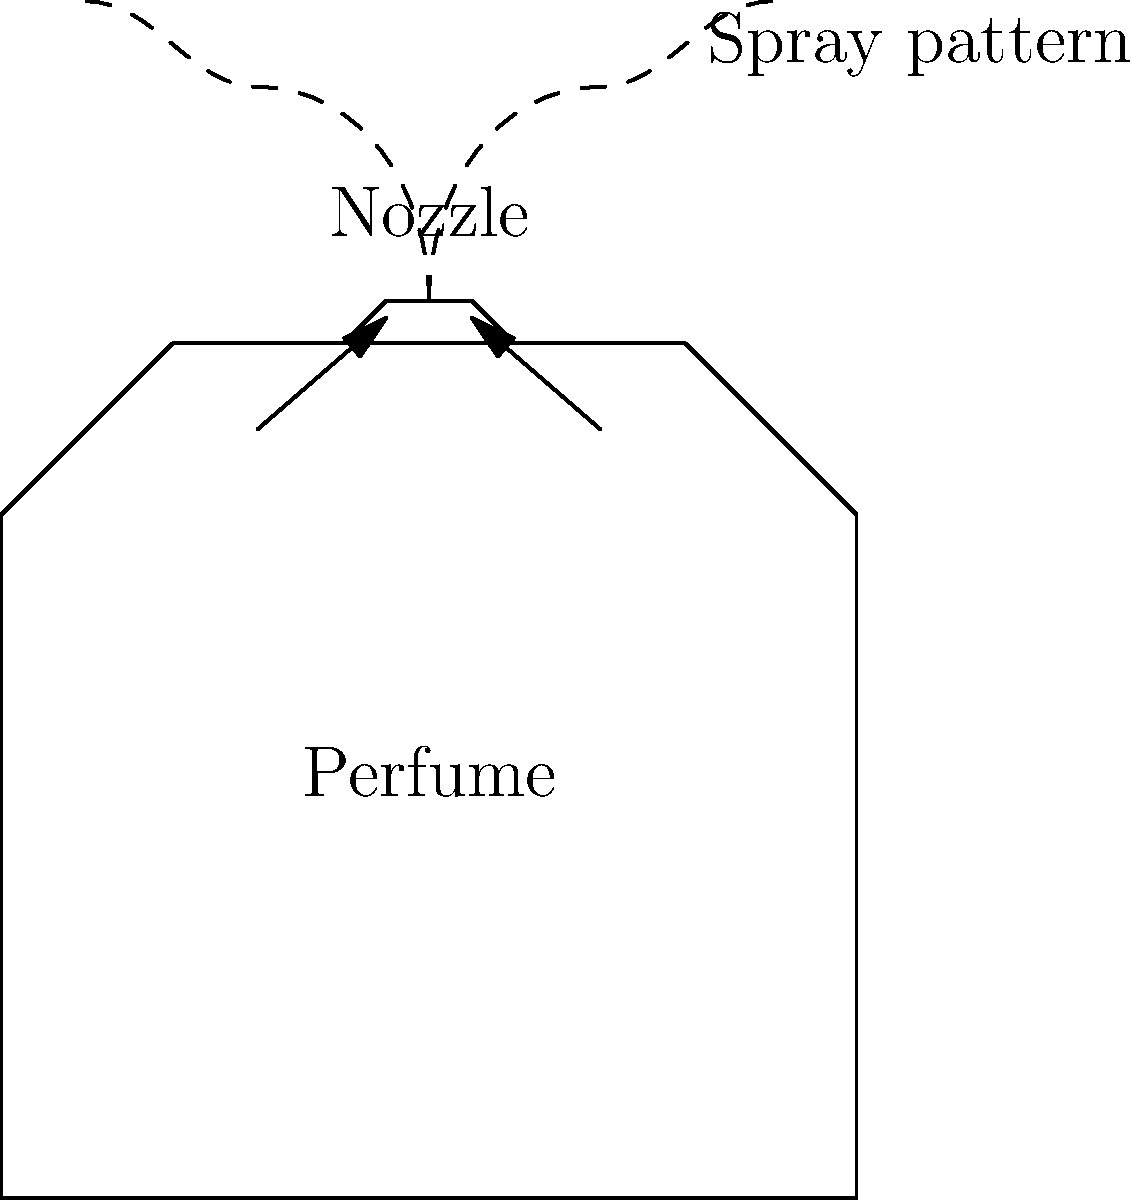In luxury perfume atomizers, the spray pattern is crucial for the perceived quality of the product. Consider a high-end perfume atomizer that produces a fine mist with a cone angle of 30°. If the initial velocity of the perfume droplets is 15 m/s and they have an average diameter of 20 μm, estimate the maximum distance these droplets can travel horizontally before falling 1 m vertically. Assume standard gravity (g = 9.81 m/s²) and neglect air resistance. To solve this problem, we'll follow these steps:

1) First, we need to determine the time it takes for the droplet to fall 1 m vertically.
   Using the equation of motion: $y = \frac{1}{2}gt^2$
   Where $y = 1$ m, $g = 9.81$ m/s²
   
   $1 = \frac{1}{2} \cdot 9.81 \cdot t^2$
   $t = \sqrt{\frac{2}{9.81}} = 0.452$ s

2) Now, we need to find the horizontal component of the initial velocity.
   The spray angle is 30°, so the horizontal component is:
   $v_x = v \cos(30°) = 15 \cdot \cos(30°) = 12.99$ m/s

3) The horizontal distance traveled is given by:
   $x = v_x \cdot t = 12.99 \cdot 0.452 = 5.87$ m

Therefore, the maximum horizontal distance the droplets can travel before falling 1 m is approximately 5.87 m.

Note: In reality, air resistance would significantly affect this result, especially for such small droplets. The actual distance would be much less.
Answer: 5.87 m 